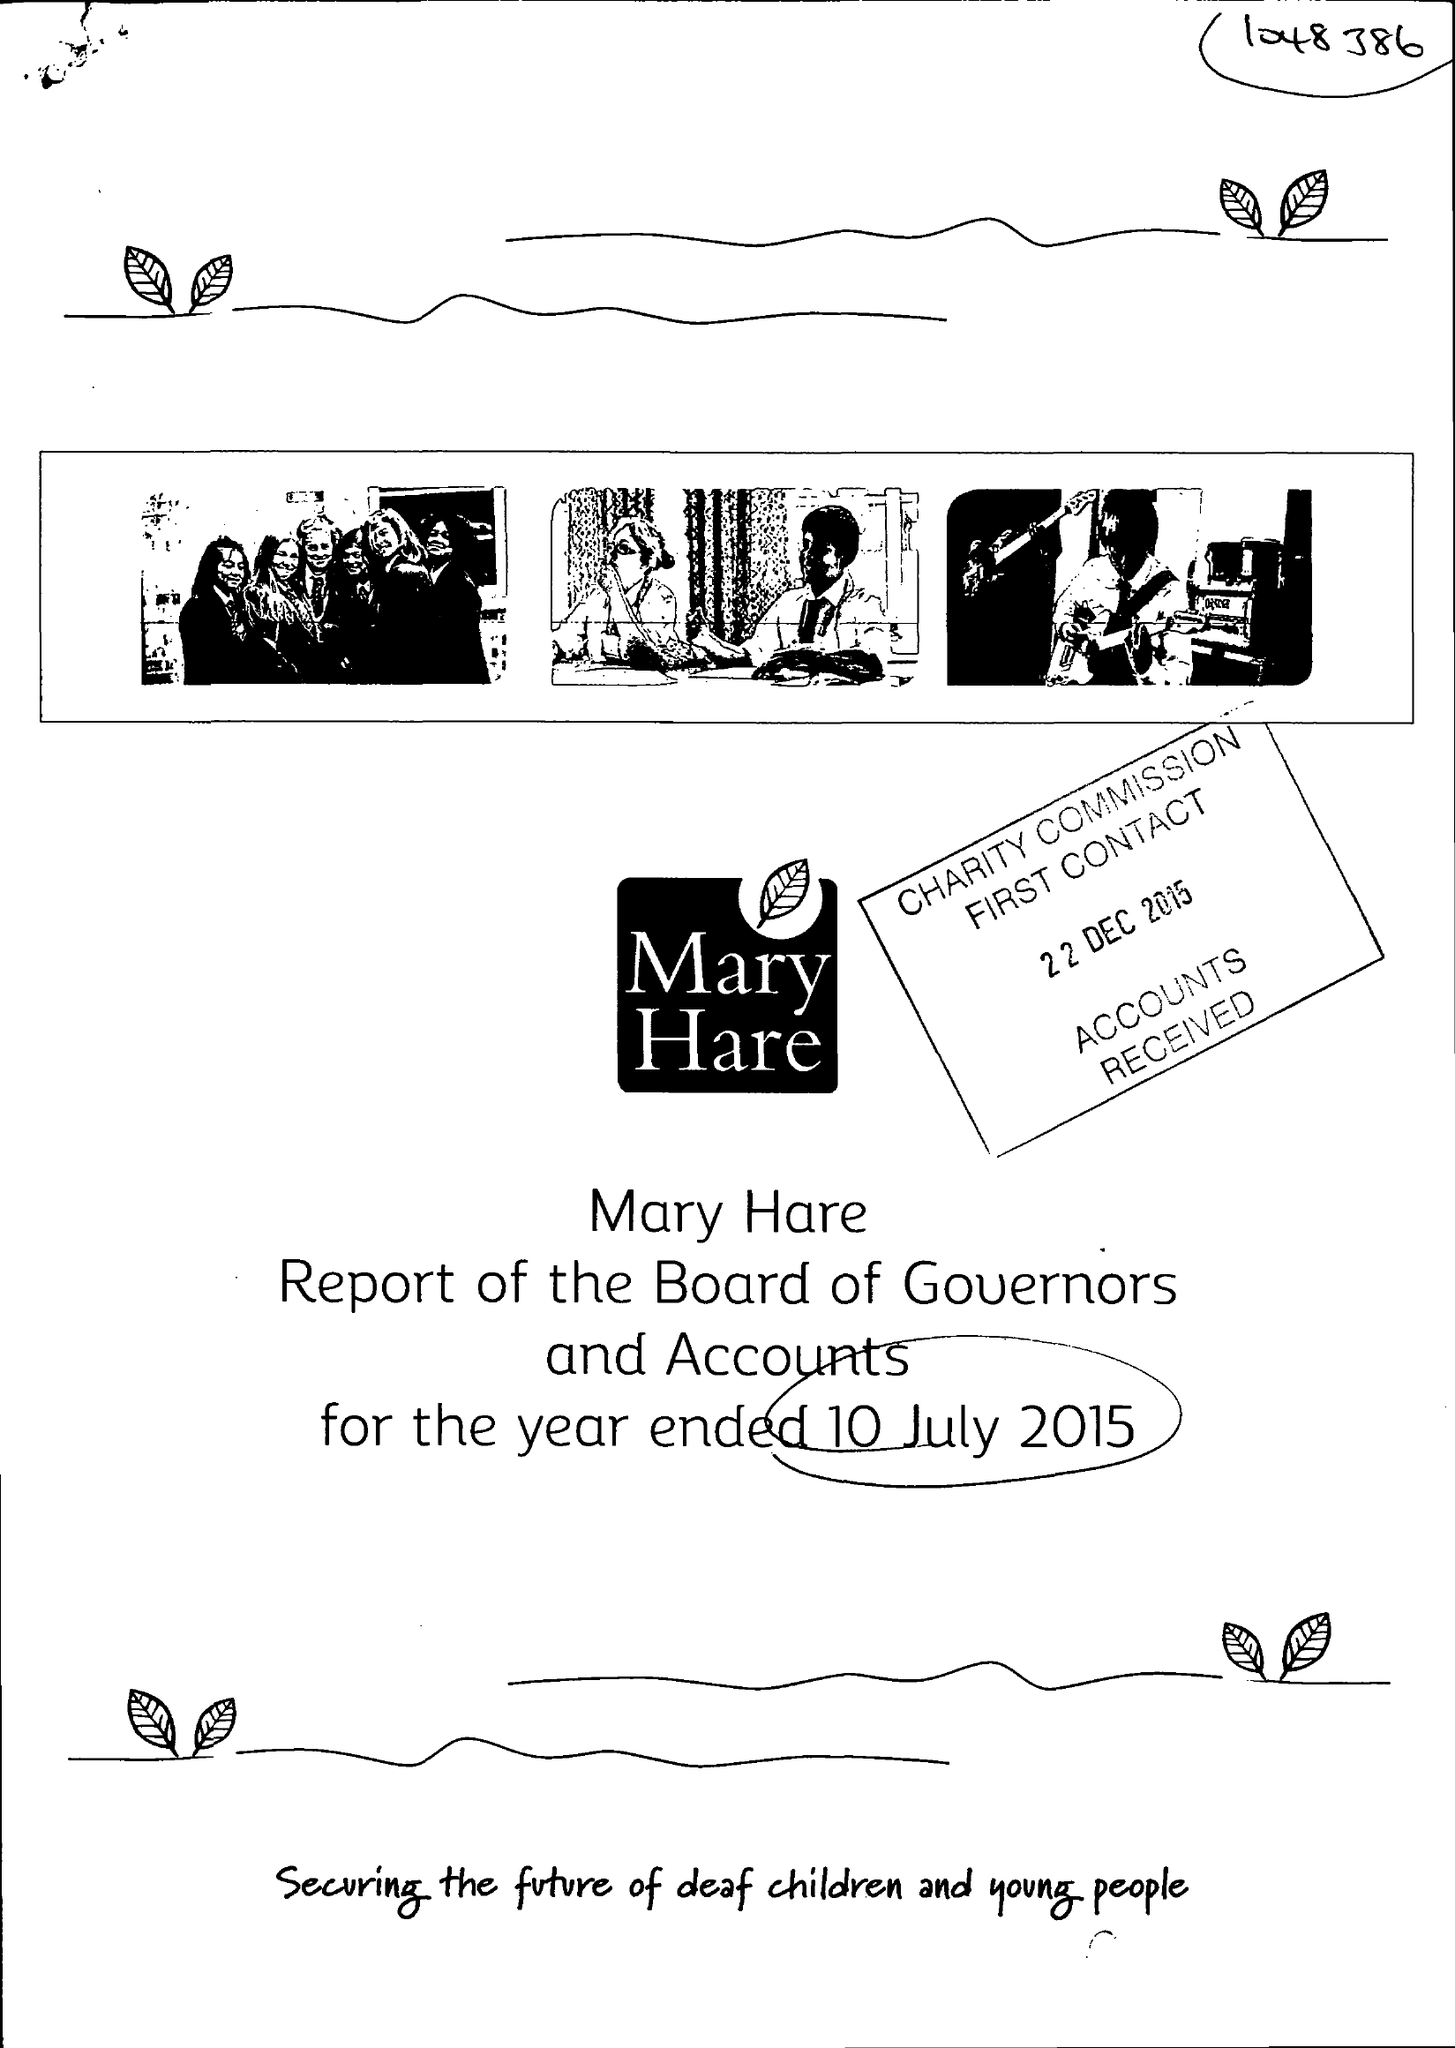What is the value for the address__street_line?
Answer the question using a single word or phrase. NEWBURY 